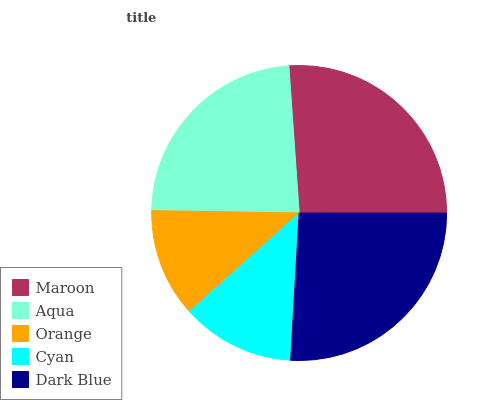Is Orange the minimum?
Answer yes or no. Yes. Is Maroon the maximum?
Answer yes or no. Yes. Is Aqua the minimum?
Answer yes or no. No. Is Aqua the maximum?
Answer yes or no. No. Is Maroon greater than Aqua?
Answer yes or no. Yes. Is Aqua less than Maroon?
Answer yes or no. Yes. Is Aqua greater than Maroon?
Answer yes or no. No. Is Maroon less than Aqua?
Answer yes or no. No. Is Aqua the high median?
Answer yes or no. Yes. Is Aqua the low median?
Answer yes or no. Yes. Is Maroon the high median?
Answer yes or no. No. Is Dark Blue the low median?
Answer yes or no. No. 